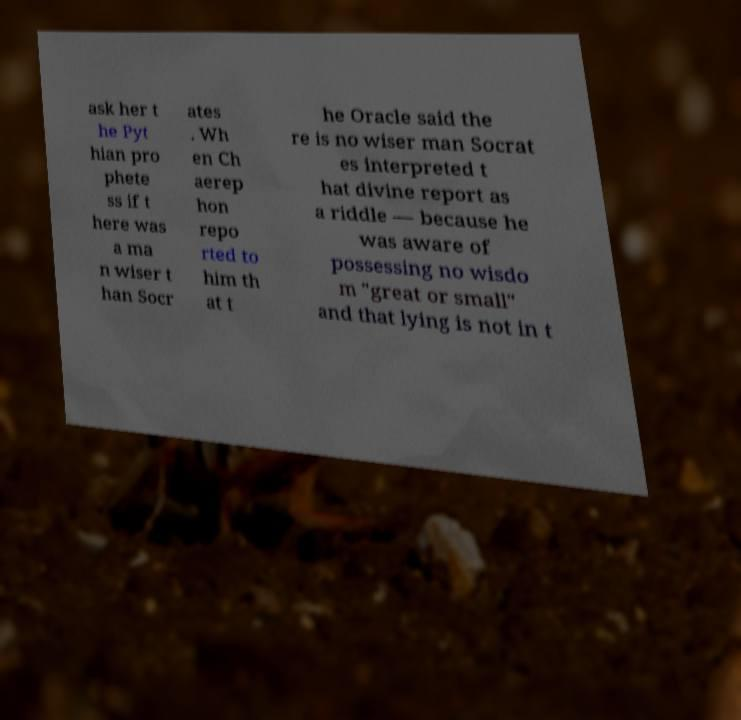For documentation purposes, I need the text within this image transcribed. Could you provide that? ask her t he Pyt hian pro phete ss if t here was a ma n wiser t han Socr ates . Wh en Ch aerep hon repo rted to him th at t he Oracle said the re is no wiser man Socrat es interpreted t hat divine report as a riddle — because he was aware of possessing no wisdo m "great or small" and that lying is not in t 